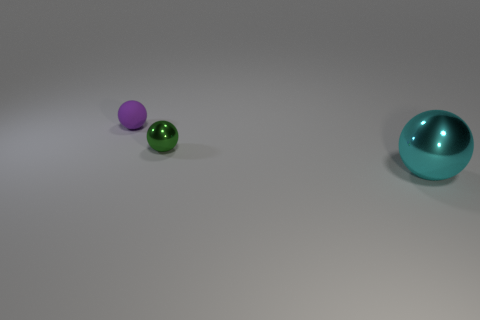Add 1 big shiny things. How many objects exist? 4 Add 1 matte spheres. How many matte spheres are left? 2 Add 2 green objects. How many green objects exist? 3 Subtract 0 brown cubes. How many objects are left? 3 Subtract all cyan metal spheres. Subtract all small shiny things. How many objects are left? 1 